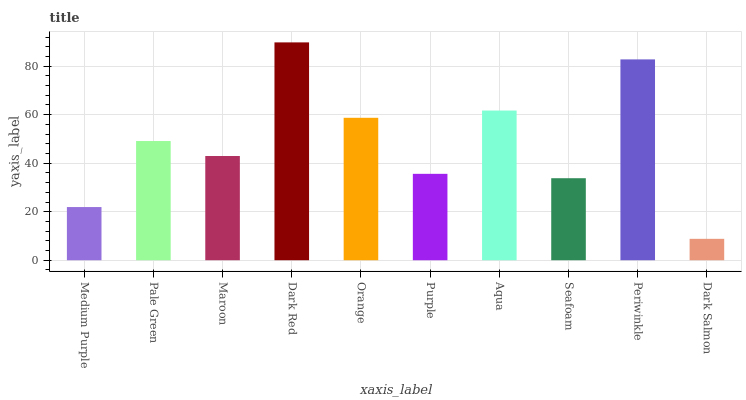Is Pale Green the minimum?
Answer yes or no. No. Is Pale Green the maximum?
Answer yes or no. No. Is Pale Green greater than Medium Purple?
Answer yes or no. Yes. Is Medium Purple less than Pale Green?
Answer yes or no. Yes. Is Medium Purple greater than Pale Green?
Answer yes or no. No. Is Pale Green less than Medium Purple?
Answer yes or no. No. Is Pale Green the high median?
Answer yes or no. Yes. Is Maroon the low median?
Answer yes or no. Yes. Is Medium Purple the high median?
Answer yes or no. No. Is Orange the low median?
Answer yes or no. No. 